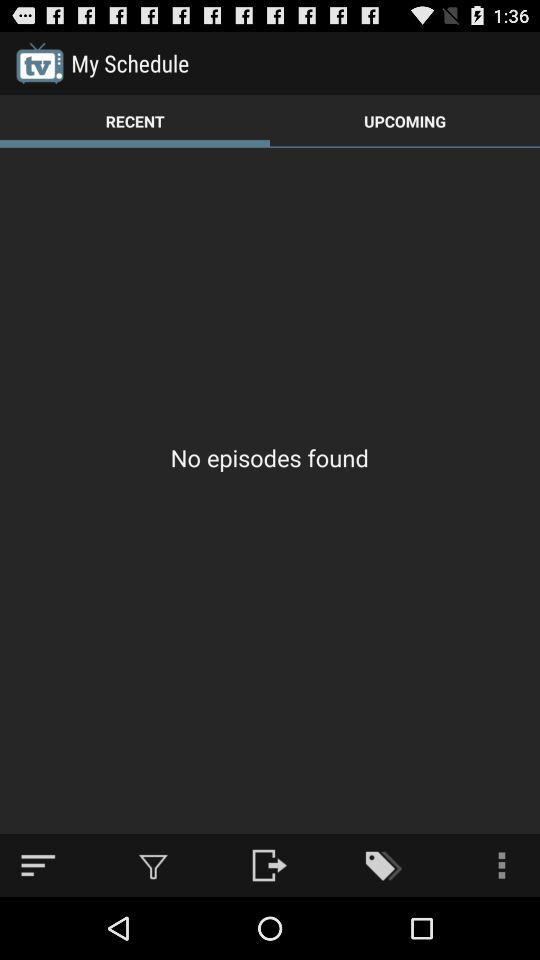Which tab is selected? The selected tab is "Recent". 